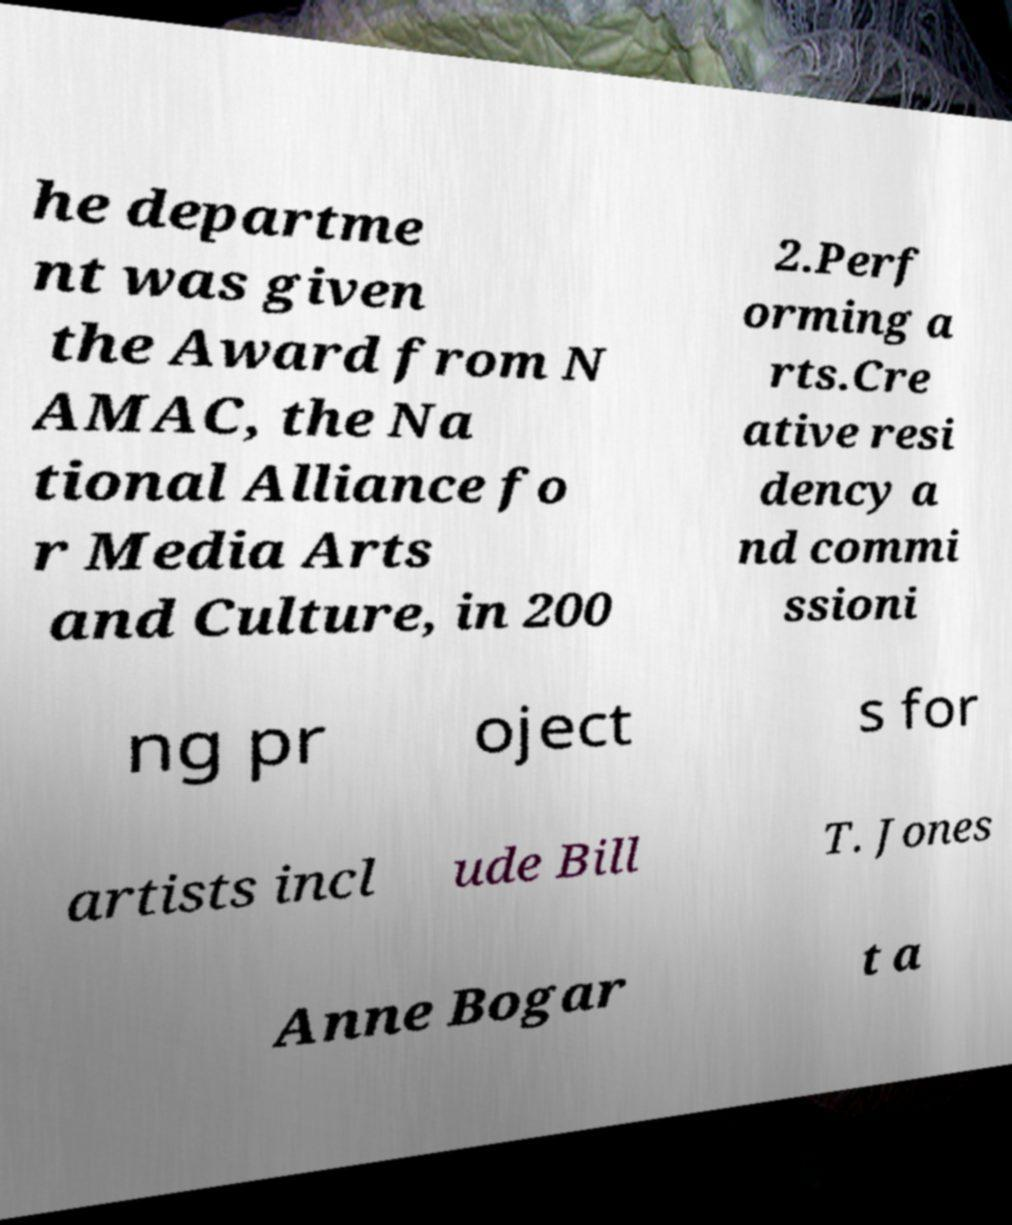Can you accurately transcribe the text from the provided image for me? he departme nt was given the Award from N AMAC, the Na tional Alliance fo r Media Arts and Culture, in 200 2.Perf orming a rts.Cre ative resi dency a nd commi ssioni ng pr oject s for artists incl ude Bill T. Jones Anne Bogar t a 